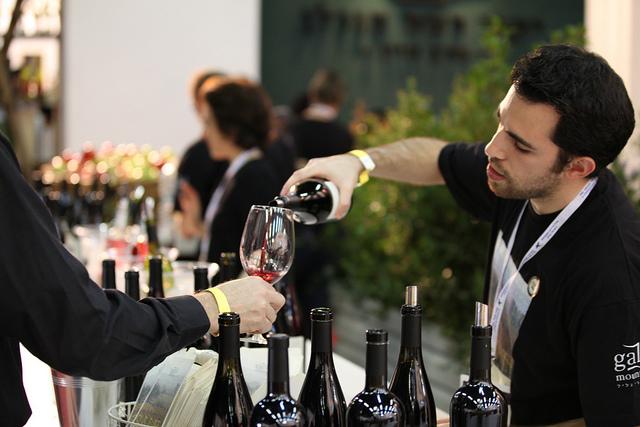What are the people wearing around their wrists?
Give a very brief answer. Bracelets. What color is the pourers shirt?
Keep it brief. Black. What is being poured?
Short answer required. Wine. 